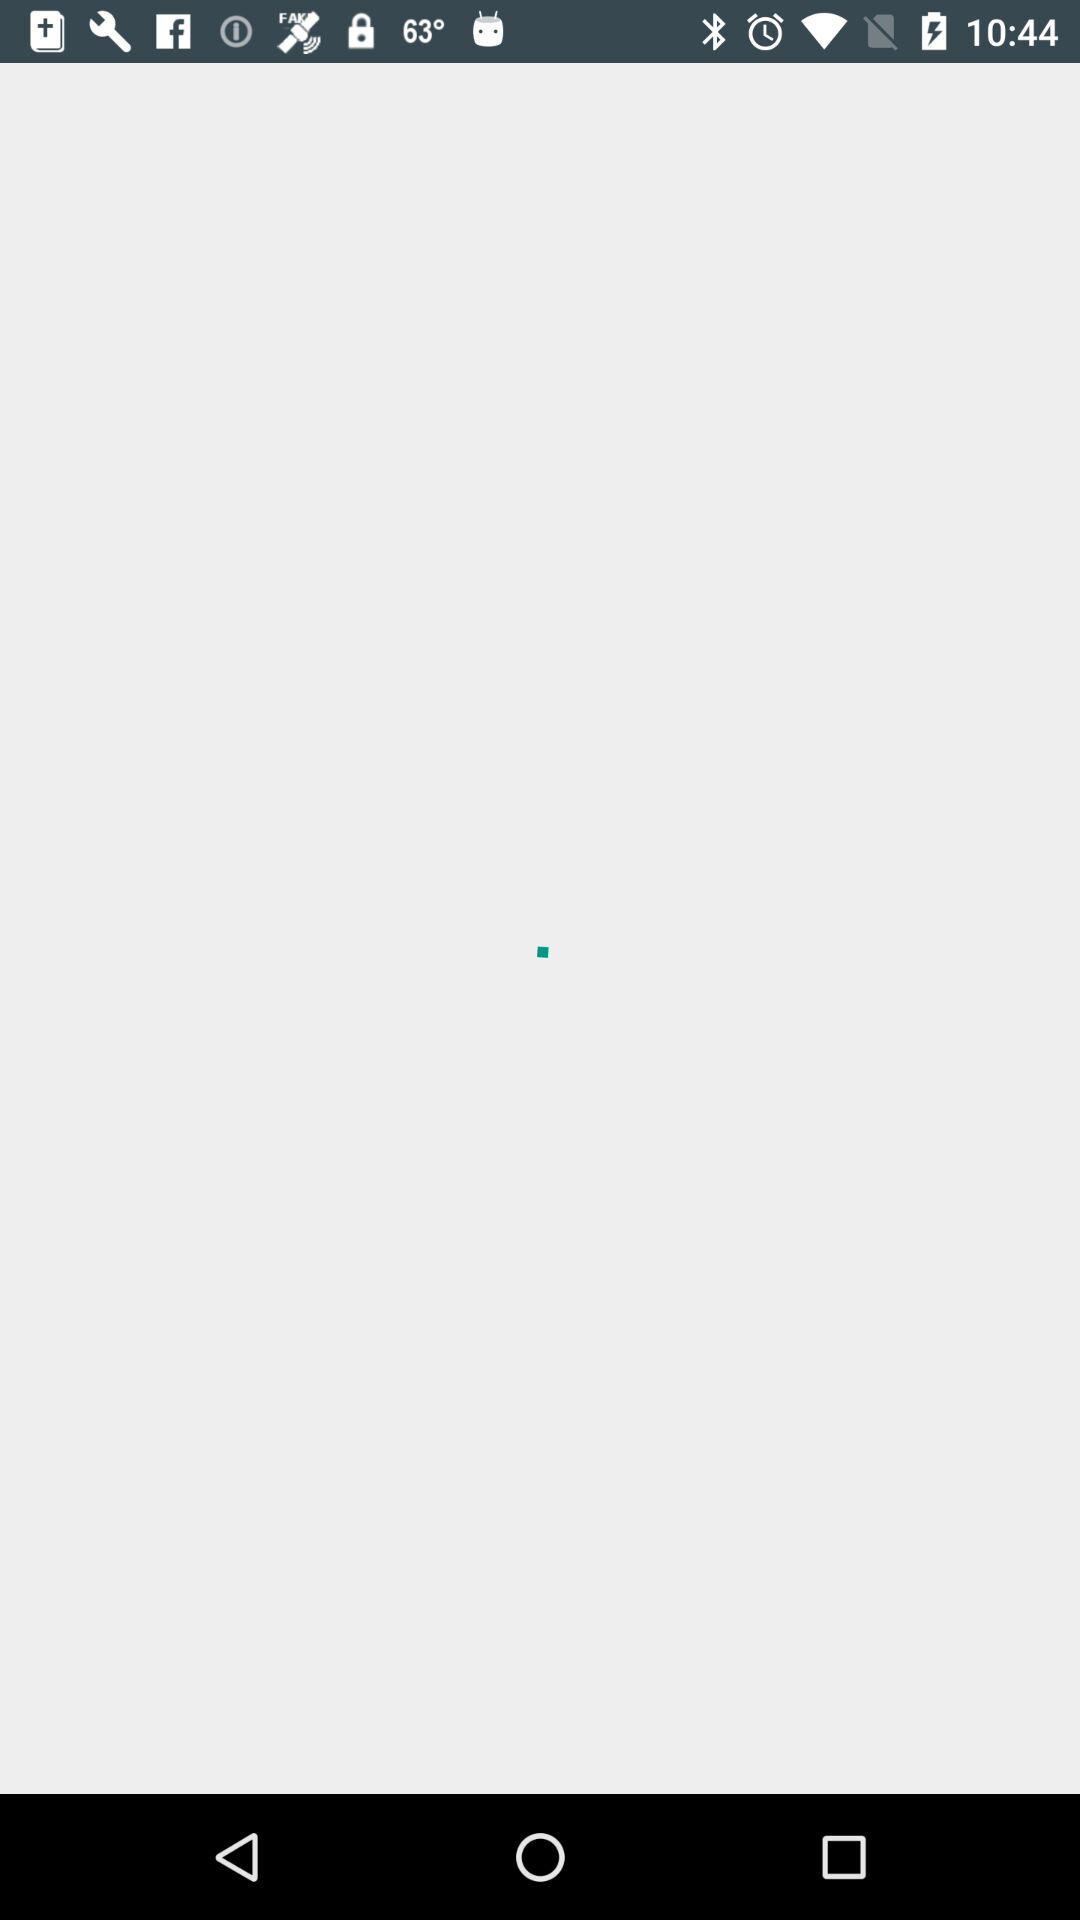Which car brand has been selected? The car brand "Buick" has been selected. 